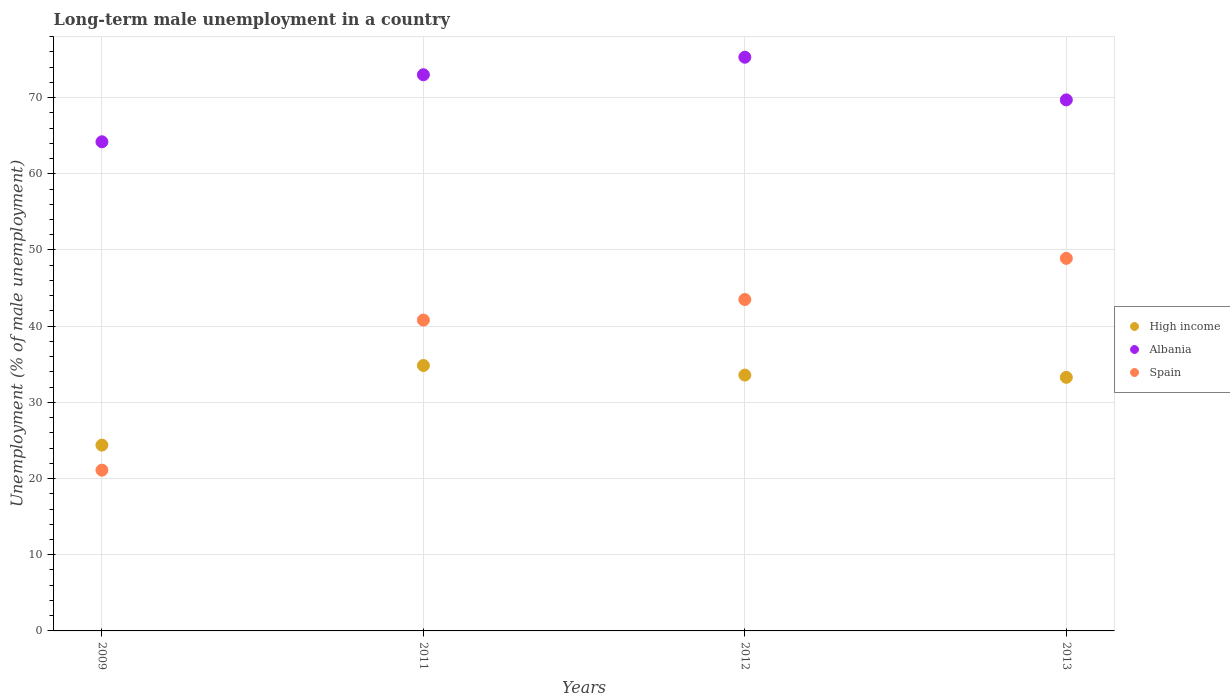What is the percentage of long-term unemployed male population in Spain in 2012?
Keep it short and to the point. 43.5. Across all years, what is the maximum percentage of long-term unemployed male population in Spain?
Your response must be concise. 48.9. Across all years, what is the minimum percentage of long-term unemployed male population in Spain?
Provide a short and direct response. 21.1. In which year was the percentage of long-term unemployed male population in Spain minimum?
Ensure brevity in your answer.  2009. What is the total percentage of long-term unemployed male population in Spain in the graph?
Make the answer very short. 154.3. What is the difference between the percentage of long-term unemployed male population in Albania in 2009 and that in 2012?
Provide a short and direct response. -11.1. What is the difference between the percentage of long-term unemployed male population in Spain in 2011 and the percentage of long-term unemployed male population in High income in 2012?
Provide a succinct answer. 7.22. What is the average percentage of long-term unemployed male population in Spain per year?
Make the answer very short. 38.58. In the year 2011, what is the difference between the percentage of long-term unemployed male population in High income and percentage of long-term unemployed male population in Albania?
Offer a very short reply. -38.16. What is the ratio of the percentage of long-term unemployed male population in Albania in 2012 to that in 2013?
Your answer should be very brief. 1.08. Is the difference between the percentage of long-term unemployed male population in High income in 2009 and 2012 greater than the difference between the percentage of long-term unemployed male population in Albania in 2009 and 2012?
Provide a short and direct response. Yes. What is the difference between the highest and the second highest percentage of long-term unemployed male population in High income?
Make the answer very short. 1.26. What is the difference between the highest and the lowest percentage of long-term unemployed male population in High income?
Provide a succinct answer. 10.45. In how many years, is the percentage of long-term unemployed male population in High income greater than the average percentage of long-term unemployed male population in High income taken over all years?
Offer a very short reply. 3. Is it the case that in every year, the sum of the percentage of long-term unemployed male population in Albania and percentage of long-term unemployed male population in Spain  is greater than the percentage of long-term unemployed male population in High income?
Give a very brief answer. Yes. Is the percentage of long-term unemployed male population in High income strictly greater than the percentage of long-term unemployed male population in Albania over the years?
Ensure brevity in your answer.  No. Is the percentage of long-term unemployed male population in Spain strictly less than the percentage of long-term unemployed male population in Albania over the years?
Make the answer very short. Yes. How many dotlines are there?
Make the answer very short. 3. What is the difference between two consecutive major ticks on the Y-axis?
Offer a terse response. 10. Are the values on the major ticks of Y-axis written in scientific E-notation?
Provide a short and direct response. No. Does the graph contain any zero values?
Your answer should be compact. No. Where does the legend appear in the graph?
Ensure brevity in your answer.  Center right. How many legend labels are there?
Offer a terse response. 3. What is the title of the graph?
Your answer should be very brief. Long-term male unemployment in a country. What is the label or title of the Y-axis?
Provide a succinct answer. Unemployment (% of male unemployment). What is the Unemployment (% of male unemployment) of High income in 2009?
Your answer should be compact. 24.39. What is the Unemployment (% of male unemployment) in Albania in 2009?
Your answer should be very brief. 64.2. What is the Unemployment (% of male unemployment) of Spain in 2009?
Your answer should be compact. 21.1. What is the Unemployment (% of male unemployment) in High income in 2011?
Provide a succinct answer. 34.84. What is the Unemployment (% of male unemployment) in Spain in 2011?
Your response must be concise. 40.8. What is the Unemployment (% of male unemployment) in High income in 2012?
Offer a very short reply. 33.58. What is the Unemployment (% of male unemployment) in Albania in 2012?
Your answer should be compact. 75.3. What is the Unemployment (% of male unemployment) in Spain in 2012?
Offer a very short reply. 43.5. What is the Unemployment (% of male unemployment) of High income in 2013?
Your response must be concise. 33.28. What is the Unemployment (% of male unemployment) in Albania in 2013?
Your answer should be compact. 69.7. What is the Unemployment (% of male unemployment) of Spain in 2013?
Make the answer very short. 48.9. Across all years, what is the maximum Unemployment (% of male unemployment) in High income?
Make the answer very short. 34.84. Across all years, what is the maximum Unemployment (% of male unemployment) in Albania?
Provide a short and direct response. 75.3. Across all years, what is the maximum Unemployment (% of male unemployment) in Spain?
Offer a very short reply. 48.9. Across all years, what is the minimum Unemployment (% of male unemployment) of High income?
Offer a terse response. 24.39. Across all years, what is the minimum Unemployment (% of male unemployment) of Albania?
Ensure brevity in your answer.  64.2. Across all years, what is the minimum Unemployment (% of male unemployment) of Spain?
Offer a very short reply. 21.1. What is the total Unemployment (% of male unemployment) in High income in the graph?
Offer a very short reply. 126.09. What is the total Unemployment (% of male unemployment) in Albania in the graph?
Your answer should be compact. 282.2. What is the total Unemployment (% of male unemployment) of Spain in the graph?
Provide a short and direct response. 154.3. What is the difference between the Unemployment (% of male unemployment) of High income in 2009 and that in 2011?
Your response must be concise. -10.45. What is the difference between the Unemployment (% of male unemployment) of Albania in 2009 and that in 2011?
Your response must be concise. -8.8. What is the difference between the Unemployment (% of male unemployment) of Spain in 2009 and that in 2011?
Your answer should be compact. -19.7. What is the difference between the Unemployment (% of male unemployment) in High income in 2009 and that in 2012?
Your answer should be very brief. -9.19. What is the difference between the Unemployment (% of male unemployment) of Albania in 2009 and that in 2012?
Keep it short and to the point. -11.1. What is the difference between the Unemployment (% of male unemployment) in Spain in 2009 and that in 2012?
Keep it short and to the point. -22.4. What is the difference between the Unemployment (% of male unemployment) in High income in 2009 and that in 2013?
Provide a succinct answer. -8.9. What is the difference between the Unemployment (% of male unemployment) of Spain in 2009 and that in 2013?
Make the answer very short. -27.8. What is the difference between the Unemployment (% of male unemployment) of High income in 2011 and that in 2012?
Keep it short and to the point. 1.26. What is the difference between the Unemployment (% of male unemployment) of Albania in 2011 and that in 2012?
Provide a short and direct response. -2.3. What is the difference between the Unemployment (% of male unemployment) in Spain in 2011 and that in 2012?
Your answer should be very brief. -2.7. What is the difference between the Unemployment (% of male unemployment) in High income in 2011 and that in 2013?
Your answer should be very brief. 1.55. What is the difference between the Unemployment (% of male unemployment) in High income in 2012 and that in 2013?
Keep it short and to the point. 0.3. What is the difference between the Unemployment (% of male unemployment) in High income in 2009 and the Unemployment (% of male unemployment) in Albania in 2011?
Your answer should be compact. -48.61. What is the difference between the Unemployment (% of male unemployment) in High income in 2009 and the Unemployment (% of male unemployment) in Spain in 2011?
Ensure brevity in your answer.  -16.41. What is the difference between the Unemployment (% of male unemployment) of Albania in 2009 and the Unemployment (% of male unemployment) of Spain in 2011?
Your response must be concise. 23.4. What is the difference between the Unemployment (% of male unemployment) in High income in 2009 and the Unemployment (% of male unemployment) in Albania in 2012?
Keep it short and to the point. -50.91. What is the difference between the Unemployment (% of male unemployment) of High income in 2009 and the Unemployment (% of male unemployment) of Spain in 2012?
Your response must be concise. -19.11. What is the difference between the Unemployment (% of male unemployment) of Albania in 2009 and the Unemployment (% of male unemployment) of Spain in 2012?
Ensure brevity in your answer.  20.7. What is the difference between the Unemployment (% of male unemployment) of High income in 2009 and the Unemployment (% of male unemployment) of Albania in 2013?
Give a very brief answer. -45.31. What is the difference between the Unemployment (% of male unemployment) of High income in 2009 and the Unemployment (% of male unemployment) of Spain in 2013?
Give a very brief answer. -24.51. What is the difference between the Unemployment (% of male unemployment) in High income in 2011 and the Unemployment (% of male unemployment) in Albania in 2012?
Provide a short and direct response. -40.46. What is the difference between the Unemployment (% of male unemployment) of High income in 2011 and the Unemployment (% of male unemployment) of Spain in 2012?
Provide a succinct answer. -8.66. What is the difference between the Unemployment (% of male unemployment) of Albania in 2011 and the Unemployment (% of male unemployment) of Spain in 2012?
Provide a short and direct response. 29.5. What is the difference between the Unemployment (% of male unemployment) of High income in 2011 and the Unemployment (% of male unemployment) of Albania in 2013?
Your answer should be compact. -34.86. What is the difference between the Unemployment (% of male unemployment) in High income in 2011 and the Unemployment (% of male unemployment) in Spain in 2013?
Make the answer very short. -14.06. What is the difference between the Unemployment (% of male unemployment) in Albania in 2011 and the Unemployment (% of male unemployment) in Spain in 2013?
Give a very brief answer. 24.1. What is the difference between the Unemployment (% of male unemployment) of High income in 2012 and the Unemployment (% of male unemployment) of Albania in 2013?
Ensure brevity in your answer.  -36.12. What is the difference between the Unemployment (% of male unemployment) in High income in 2012 and the Unemployment (% of male unemployment) in Spain in 2013?
Ensure brevity in your answer.  -15.32. What is the difference between the Unemployment (% of male unemployment) of Albania in 2012 and the Unemployment (% of male unemployment) of Spain in 2013?
Keep it short and to the point. 26.4. What is the average Unemployment (% of male unemployment) in High income per year?
Offer a very short reply. 31.52. What is the average Unemployment (% of male unemployment) of Albania per year?
Your answer should be very brief. 70.55. What is the average Unemployment (% of male unemployment) in Spain per year?
Provide a short and direct response. 38.58. In the year 2009, what is the difference between the Unemployment (% of male unemployment) in High income and Unemployment (% of male unemployment) in Albania?
Offer a terse response. -39.81. In the year 2009, what is the difference between the Unemployment (% of male unemployment) of High income and Unemployment (% of male unemployment) of Spain?
Provide a short and direct response. 3.29. In the year 2009, what is the difference between the Unemployment (% of male unemployment) of Albania and Unemployment (% of male unemployment) of Spain?
Your response must be concise. 43.1. In the year 2011, what is the difference between the Unemployment (% of male unemployment) of High income and Unemployment (% of male unemployment) of Albania?
Ensure brevity in your answer.  -38.16. In the year 2011, what is the difference between the Unemployment (% of male unemployment) of High income and Unemployment (% of male unemployment) of Spain?
Your answer should be compact. -5.96. In the year 2011, what is the difference between the Unemployment (% of male unemployment) of Albania and Unemployment (% of male unemployment) of Spain?
Your response must be concise. 32.2. In the year 2012, what is the difference between the Unemployment (% of male unemployment) of High income and Unemployment (% of male unemployment) of Albania?
Your answer should be compact. -41.72. In the year 2012, what is the difference between the Unemployment (% of male unemployment) of High income and Unemployment (% of male unemployment) of Spain?
Offer a terse response. -9.92. In the year 2012, what is the difference between the Unemployment (% of male unemployment) of Albania and Unemployment (% of male unemployment) of Spain?
Give a very brief answer. 31.8. In the year 2013, what is the difference between the Unemployment (% of male unemployment) of High income and Unemployment (% of male unemployment) of Albania?
Your answer should be compact. -36.42. In the year 2013, what is the difference between the Unemployment (% of male unemployment) of High income and Unemployment (% of male unemployment) of Spain?
Make the answer very short. -15.62. In the year 2013, what is the difference between the Unemployment (% of male unemployment) of Albania and Unemployment (% of male unemployment) of Spain?
Keep it short and to the point. 20.8. What is the ratio of the Unemployment (% of male unemployment) in Albania in 2009 to that in 2011?
Your answer should be compact. 0.88. What is the ratio of the Unemployment (% of male unemployment) in Spain in 2009 to that in 2011?
Your response must be concise. 0.52. What is the ratio of the Unemployment (% of male unemployment) of High income in 2009 to that in 2012?
Ensure brevity in your answer.  0.73. What is the ratio of the Unemployment (% of male unemployment) in Albania in 2009 to that in 2012?
Offer a terse response. 0.85. What is the ratio of the Unemployment (% of male unemployment) of Spain in 2009 to that in 2012?
Keep it short and to the point. 0.49. What is the ratio of the Unemployment (% of male unemployment) of High income in 2009 to that in 2013?
Keep it short and to the point. 0.73. What is the ratio of the Unemployment (% of male unemployment) of Albania in 2009 to that in 2013?
Provide a succinct answer. 0.92. What is the ratio of the Unemployment (% of male unemployment) of Spain in 2009 to that in 2013?
Ensure brevity in your answer.  0.43. What is the ratio of the Unemployment (% of male unemployment) of High income in 2011 to that in 2012?
Your response must be concise. 1.04. What is the ratio of the Unemployment (% of male unemployment) in Albania in 2011 to that in 2012?
Ensure brevity in your answer.  0.97. What is the ratio of the Unemployment (% of male unemployment) in Spain in 2011 to that in 2012?
Make the answer very short. 0.94. What is the ratio of the Unemployment (% of male unemployment) of High income in 2011 to that in 2013?
Your answer should be very brief. 1.05. What is the ratio of the Unemployment (% of male unemployment) in Albania in 2011 to that in 2013?
Offer a terse response. 1.05. What is the ratio of the Unemployment (% of male unemployment) in Spain in 2011 to that in 2013?
Offer a very short reply. 0.83. What is the ratio of the Unemployment (% of male unemployment) in High income in 2012 to that in 2013?
Your answer should be very brief. 1.01. What is the ratio of the Unemployment (% of male unemployment) of Albania in 2012 to that in 2013?
Your response must be concise. 1.08. What is the ratio of the Unemployment (% of male unemployment) in Spain in 2012 to that in 2013?
Offer a very short reply. 0.89. What is the difference between the highest and the second highest Unemployment (% of male unemployment) of High income?
Offer a very short reply. 1.26. What is the difference between the highest and the second highest Unemployment (% of male unemployment) of Spain?
Provide a succinct answer. 5.4. What is the difference between the highest and the lowest Unemployment (% of male unemployment) in High income?
Ensure brevity in your answer.  10.45. What is the difference between the highest and the lowest Unemployment (% of male unemployment) of Spain?
Provide a succinct answer. 27.8. 